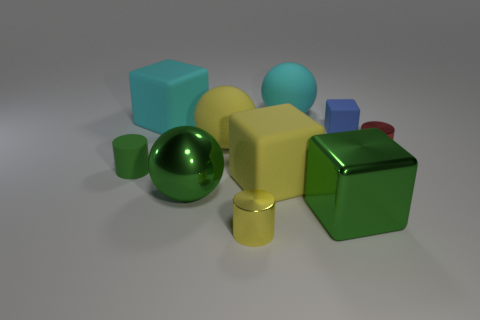Subtract all cylinders. How many objects are left? 7 Subtract all small red cylinders. Subtract all green cylinders. How many objects are left? 8 Add 2 large cyan objects. How many large cyan objects are left? 4 Add 1 tiny cyan rubber blocks. How many tiny cyan rubber blocks exist? 1 Subtract 0 purple cubes. How many objects are left? 10 